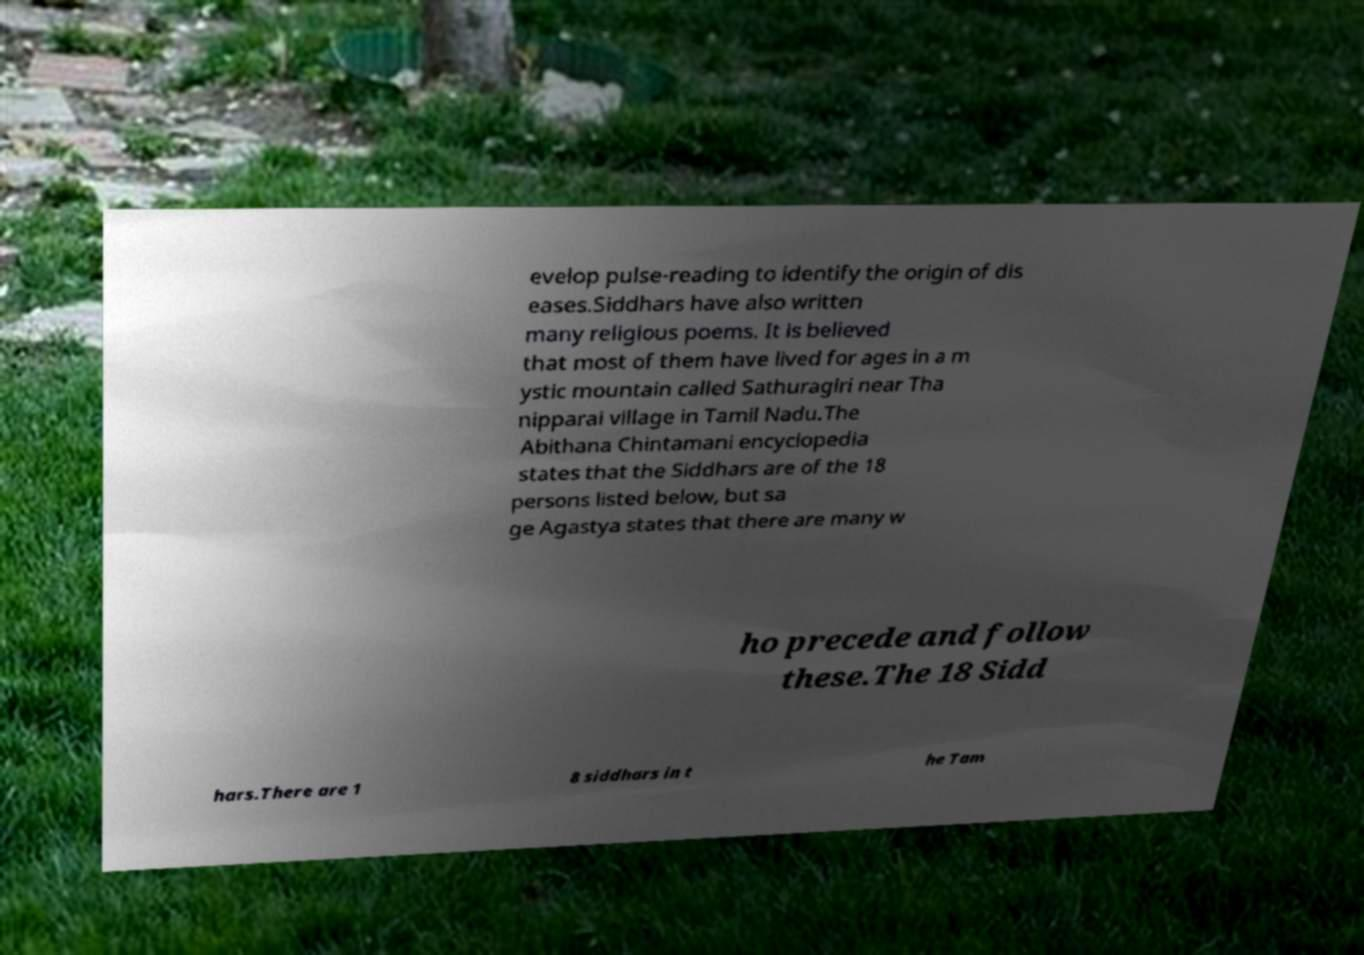Can you read and provide the text displayed in the image?This photo seems to have some interesting text. Can you extract and type it out for me? evelop pulse-reading to identify the origin of dis eases.Siddhars have also written many religious poems. It is believed that most of them have lived for ages in a m ystic mountain called Sathuragiri near Tha nipparai village in Tamil Nadu.The Abithana Chintamani encyclopedia states that the Siddhars are of the 18 persons listed below, but sa ge Agastya states that there are many w ho precede and follow these.The 18 Sidd hars.There are 1 8 siddhars in t he Tam 